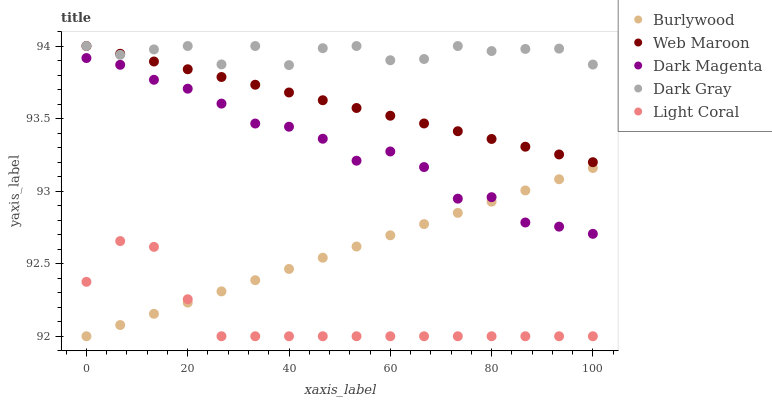Does Light Coral have the minimum area under the curve?
Answer yes or no. Yes. Does Dark Gray have the maximum area under the curve?
Answer yes or no. Yes. Does Web Maroon have the minimum area under the curve?
Answer yes or no. No. Does Web Maroon have the maximum area under the curve?
Answer yes or no. No. Is Web Maroon the smoothest?
Answer yes or no. Yes. Is Dark Gray the roughest?
Answer yes or no. Yes. Is Dark Gray the smoothest?
Answer yes or no. No. Is Web Maroon the roughest?
Answer yes or no. No. Does Burlywood have the lowest value?
Answer yes or no. Yes. Does Web Maroon have the lowest value?
Answer yes or no. No. Does Web Maroon have the highest value?
Answer yes or no. Yes. Does Dark Magenta have the highest value?
Answer yes or no. No. Is Dark Magenta less than Web Maroon?
Answer yes or no. Yes. Is Web Maroon greater than Burlywood?
Answer yes or no. Yes. Does Burlywood intersect Dark Magenta?
Answer yes or no. Yes. Is Burlywood less than Dark Magenta?
Answer yes or no. No. Is Burlywood greater than Dark Magenta?
Answer yes or no. No. Does Dark Magenta intersect Web Maroon?
Answer yes or no. No. 